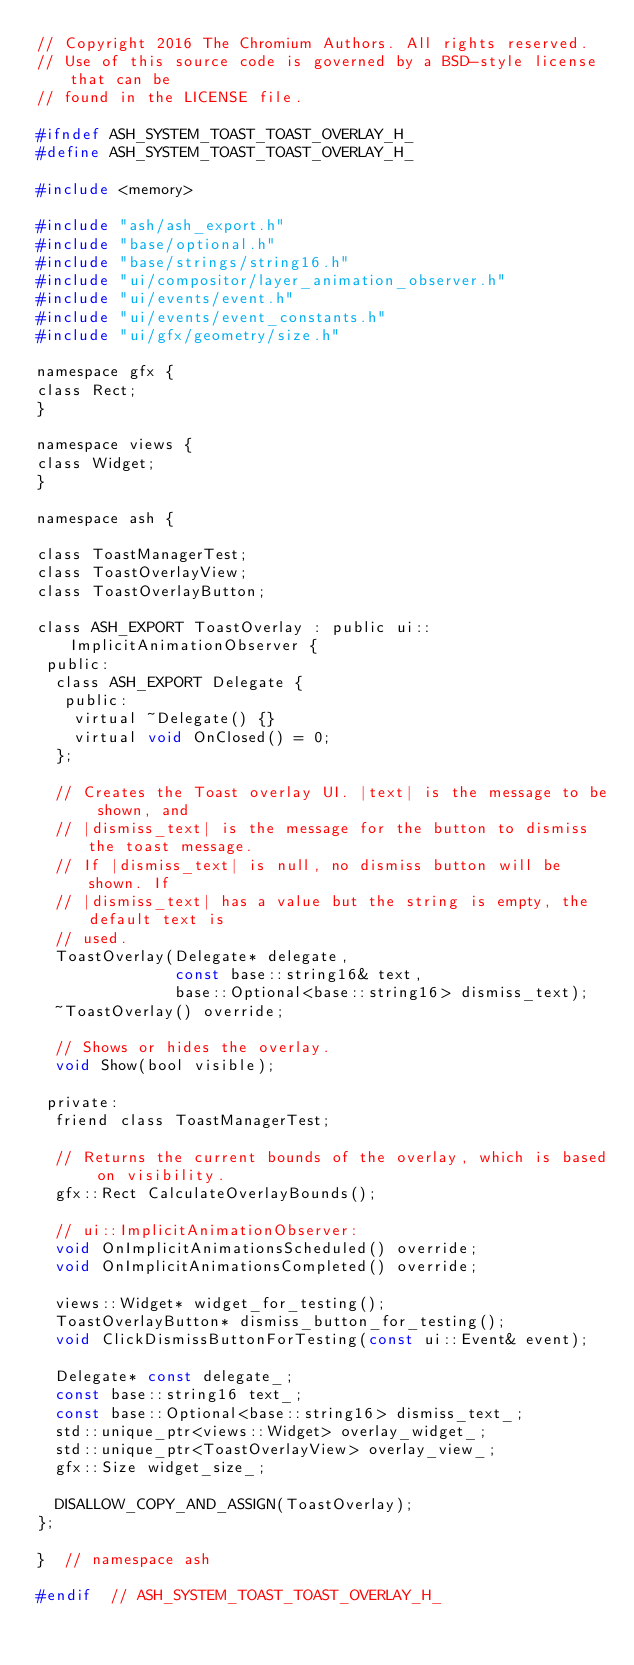Convert code to text. <code><loc_0><loc_0><loc_500><loc_500><_C_>// Copyright 2016 The Chromium Authors. All rights reserved.
// Use of this source code is governed by a BSD-style license that can be
// found in the LICENSE file.

#ifndef ASH_SYSTEM_TOAST_TOAST_OVERLAY_H_
#define ASH_SYSTEM_TOAST_TOAST_OVERLAY_H_

#include <memory>

#include "ash/ash_export.h"
#include "base/optional.h"
#include "base/strings/string16.h"
#include "ui/compositor/layer_animation_observer.h"
#include "ui/events/event.h"
#include "ui/events/event_constants.h"
#include "ui/gfx/geometry/size.h"

namespace gfx {
class Rect;
}

namespace views {
class Widget;
}

namespace ash {

class ToastManagerTest;
class ToastOverlayView;
class ToastOverlayButton;

class ASH_EXPORT ToastOverlay : public ui::ImplicitAnimationObserver {
 public:
  class ASH_EXPORT Delegate {
   public:
    virtual ~Delegate() {}
    virtual void OnClosed() = 0;
  };

  // Creates the Toast overlay UI. |text| is the message to be shown, and
  // |dismiss_text| is the message for the button to dismiss the toast message.
  // If |dismiss_text| is null, no dismiss button will be shown. If
  // |dismiss_text| has a value but the string is empty, the default text is
  // used.
  ToastOverlay(Delegate* delegate,
               const base::string16& text,
               base::Optional<base::string16> dismiss_text);
  ~ToastOverlay() override;

  // Shows or hides the overlay.
  void Show(bool visible);

 private:
  friend class ToastManagerTest;

  // Returns the current bounds of the overlay, which is based on visibility.
  gfx::Rect CalculateOverlayBounds();

  // ui::ImplicitAnimationObserver:
  void OnImplicitAnimationsScheduled() override;
  void OnImplicitAnimationsCompleted() override;

  views::Widget* widget_for_testing();
  ToastOverlayButton* dismiss_button_for_testing();
  void ClickDismissButtonForTesting(const ui::Event& event);

  Delegate* const delegate_;
  const base::string16 text_;
  const base::Optional<base::string16> dismiss_text_;
  std::unique_ptr<views::Widget> overlay_widget_;
  std::unique_ptr<ToastOverlayView> overlay_view_;
  gfx::Size widget_size_;

  DISALLOW_COPY_AND_ASSIGN(ToastOverlay);
};

}  // namespace ash

#endif  // ASH_SYSTEM_TOAST_TOAST_OVERLAY_H_
</code> 